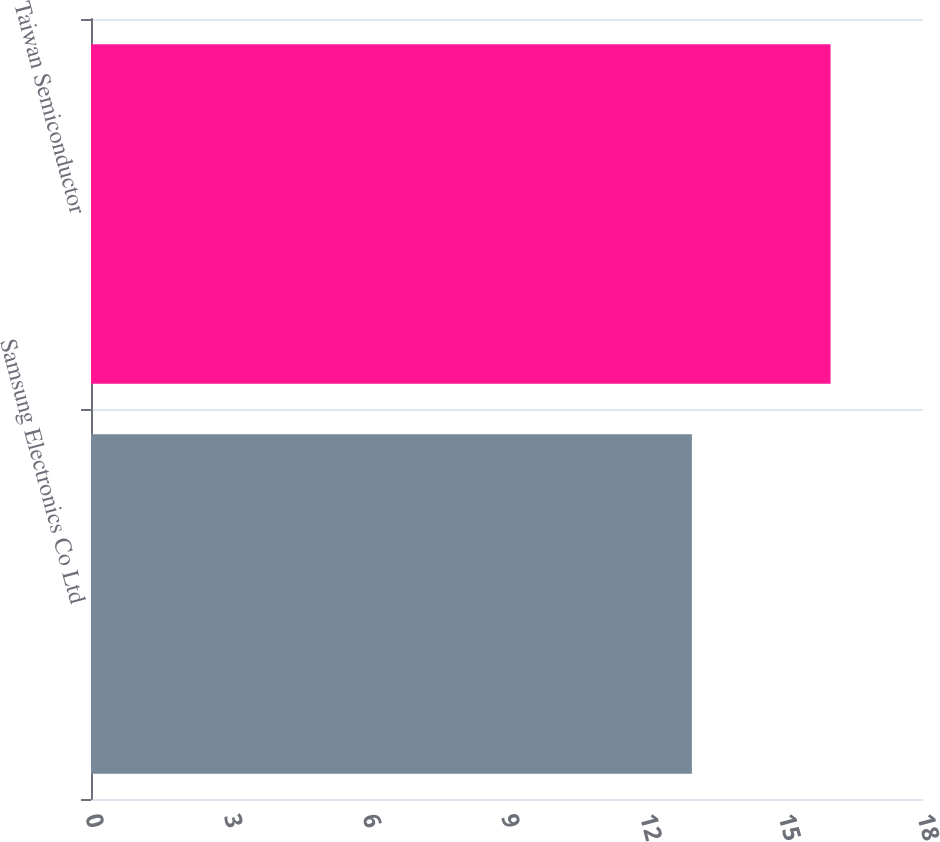Convert chart. <chart><loc_0><loc_0><loc_500><loc_500><bar_chart><fcel>Samsung Electronics Co Ltd<fcel>Taiwan Semiconductor<nl><fcel>13<fcel>16<nl></chart> 